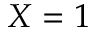Convert formula to latex. <formula><loc_0><loc_0><loc_500><loc_500>X = 1</formula> 